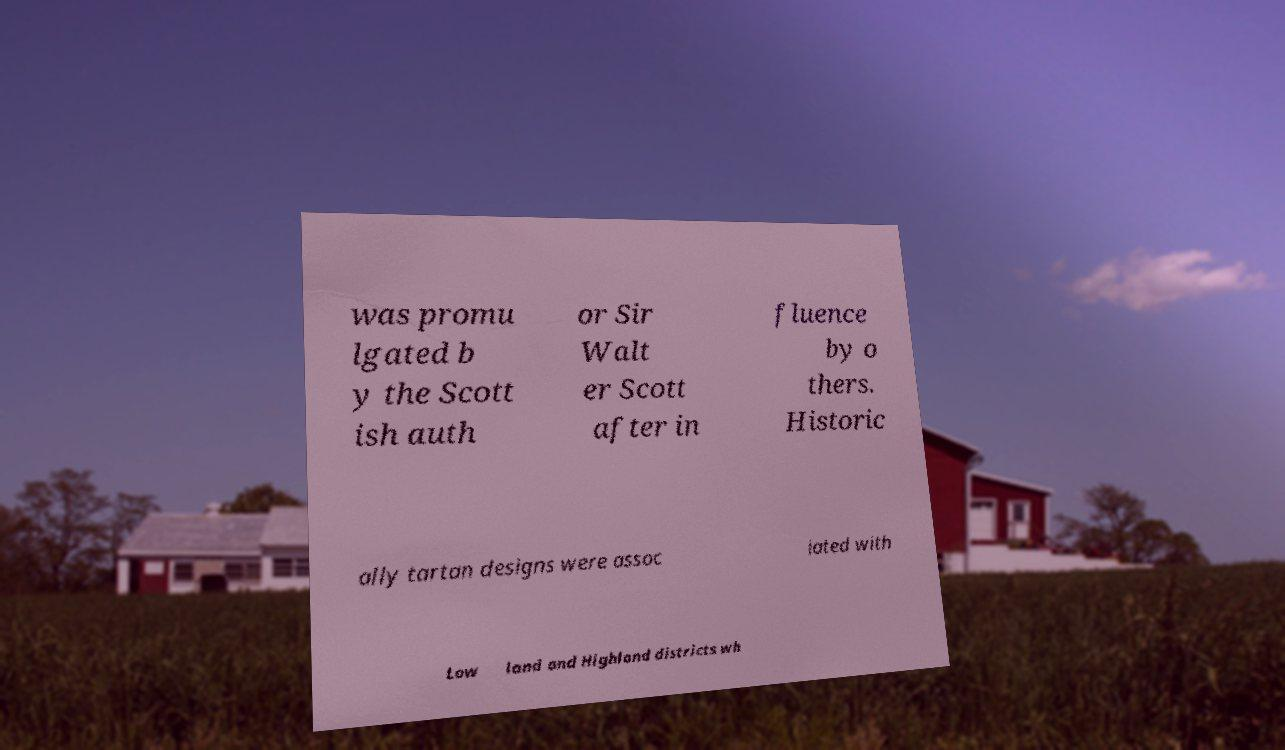For documentation purposes, I need the text within this image transcribed. Could you provide that? was promu lgated b y the Scott ish auth or Sir Walt er Scott after in fluence by o thers. Historic ally tartan designs were assoc iated with Low land and Highland districts wh 